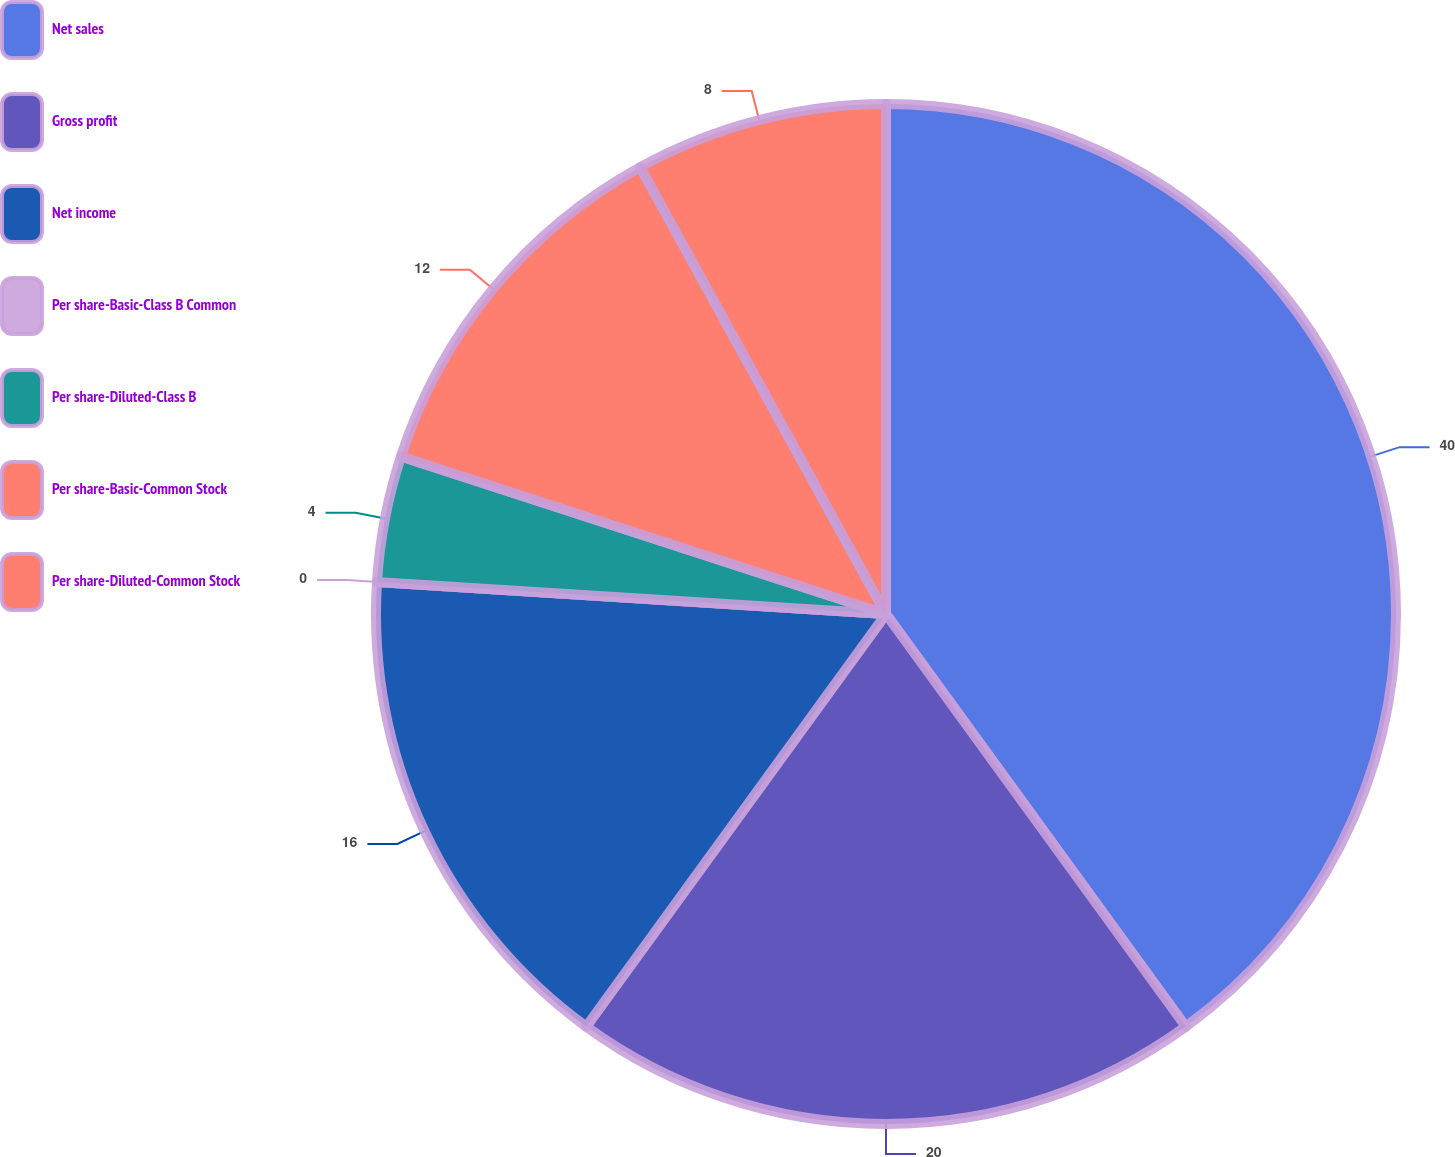Convert chart to OTSL. <chart><loc_0><loc_0><loc_500><loc_500><pie_chart><fcel>Net sales<fcel>Gross profit<fcel>Net income<fcel>Per share-Basic-Class B Common<fcel>Per share-Diluted-Class B<fcel>Per share-Basic-Common Stock<fcel>Per share-Diluted-Common Stock<nl><fcel>40.0%<fcel>20.0%<fcel>16.0%<fcel>0.0%<fcel>4.0%<fcel>12.0%<fcel>8.0%<nl></chart> 